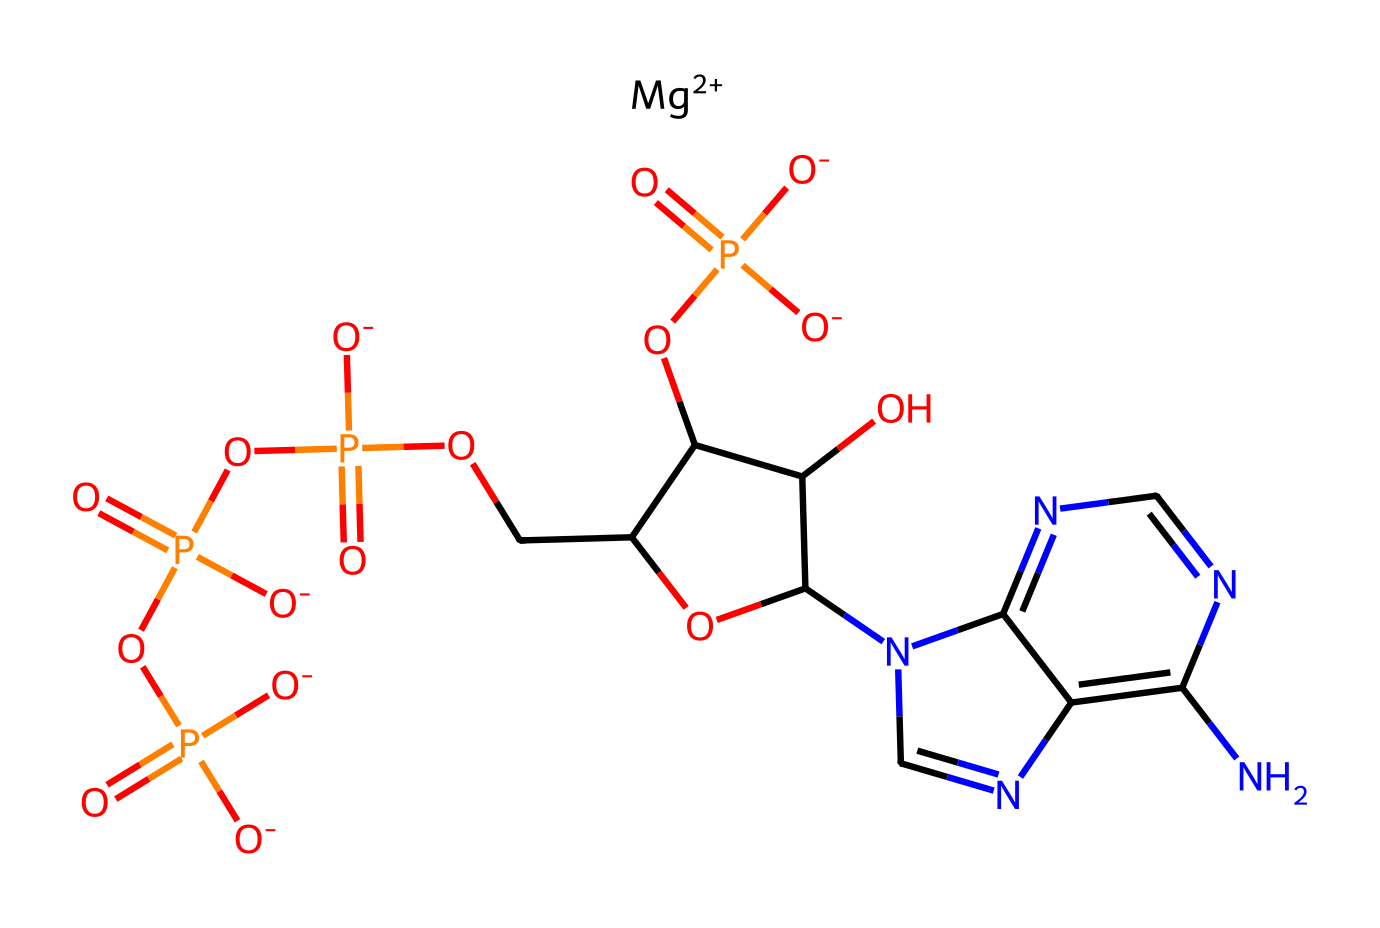What is the central metal ion in the magnesium-ATP complex? The provided SMILES representation includes "[Mg+2]", indicating that magnesium is the metal ion.
Answer: magnesium How many phosphate groups are present in this chemical structure? By examining the chemical structure, there are four phosphate groups indicated by "P(=O)" sequences.
Answer: four What is the charge of the magnesium ion in the complex? The SMILES notation shows "[Mg+2]", which denotes a +2 charge on the magnesium ion.
Answer: +2 Which functional group is responsible for the energy transfer in this compound? The phosphate (P-O) groups are known for their high-energy bonds, specifically the triphosphate structure present in ATP.
Answer: phosphate What type of compound is represented by this chemical structure? The presence of the magnesium ion coordinating with the ATP structure categorizes this as a coordination compound.
Answer: coordination compound How many nitrogen atoms are found in the cyclic structure? Counting the nitrogen atoms indicated by "n" in the cyclic part of the structure leads to a total of five nitrogen atoms.
Answer: five 